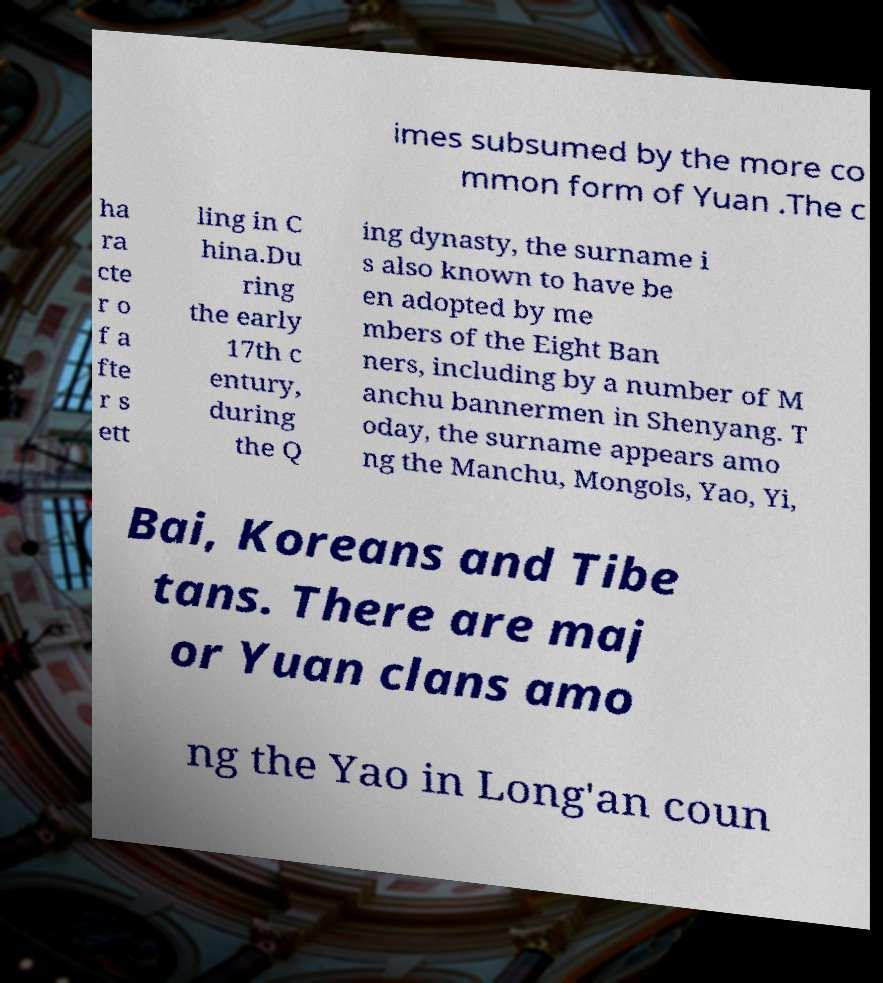Could you extract and type out the text from this image? imes subsumed by the more co mmon form of Yuan .The c ha ra cte r o f a fte r s ett ling in C hina.Du ring the early 17th c entury, during the Q ing dynasty, the surname i s also known to have be en adopted by me mbers of the Eight Ban ners, including by a number of M anchu bannermen in Shenyang. T oday, the surname appears amo ng the Manchu, Mongols, Yao, Yi, Bai, Koreans and Tibe tans. There are maj or Yuan clans amo ng the Yao in Long'an coun 